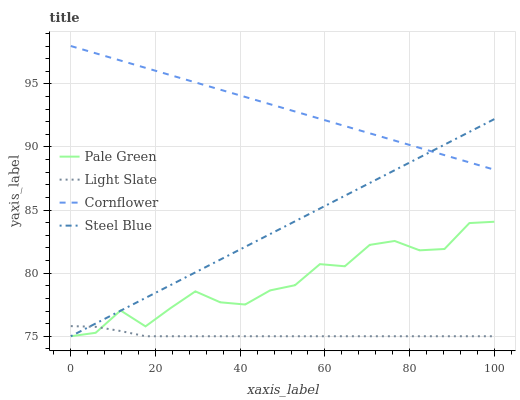Does Light Slate have the minimum area under the curve?
Answer yes or no. Yes. Does Cornflower have the maximum area under the curve?
Answer yes or no. Yes. Does Pale Green have the minimum area under the curve?
Answer yes or no. No. Does Pale Green have the maximum area under the curve?
Answer yes or no. No. Is Cornflower the smoothest?
Answer yes or no. Yes. Is Pale Green the roughest?
Answer yes or no. Yes. Is Pale Green the smoothest?
Answer yes or no. No. Is Cornflower the roughest?
Answer yes or no. No. Does Light Slate have the lowest value?
Answer yes or no. Yes. Does Cornflower have the lowest value?
Answer yes or no. No. Does Cornflower have the highest value?
Answer yes or no. Yes. Does Pale Green have the highest value?
Answer yes or no. No. Is Pale Green less than Cornflower?
Answer yes or no. Yes. Is Cornflower greater than Pale Green?
Answer yes or no. Yes. Does Light Slate intersect Steel Blue?
Answer yes or no. Yes. Is Light Slate less than Steel Blue?
Answer yes or no. No. Is Light Slate greater than Steel Blue?
Answer yes or no. No. Does Pale Green intersect Cornflower?
Answer yes or no. No. 